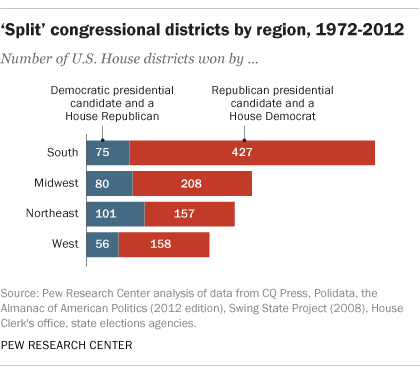Mention a couple of crucial points in this snapshot. The first red bar from the top is the largest bar, and it is. 